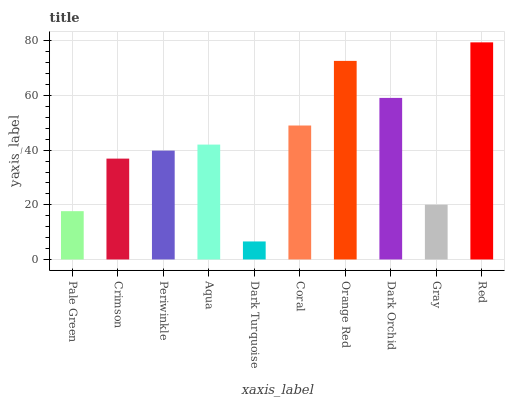Is Dark Turquoise the minimum?
Answer yes or no. Yes. Is Red the maximum?
Answer yes or no. Yes. Is Crimson the minimum?
Answer yes or no. No. Is Crimson the maximum?
Answer yes or no. No. Is Crimson greater than Pale Green?
Answer yes or no. Yes. Is Pale Green less than Crimson?
Answer yes or no. Yes. Is Pale Green greater than Crimson?
Answer yes or no. No. Is Crimson less than Pale Green?
Answer yes or no. No. Is Aqua the high median?
Answer yes or no. Yes. Is Periwinkle the low median?
Answer yes or no. Yes. Is Dark Orchid the high median?
Answer yes or no. No. Is Pale Green the low median?
Answer yes or no. No. 